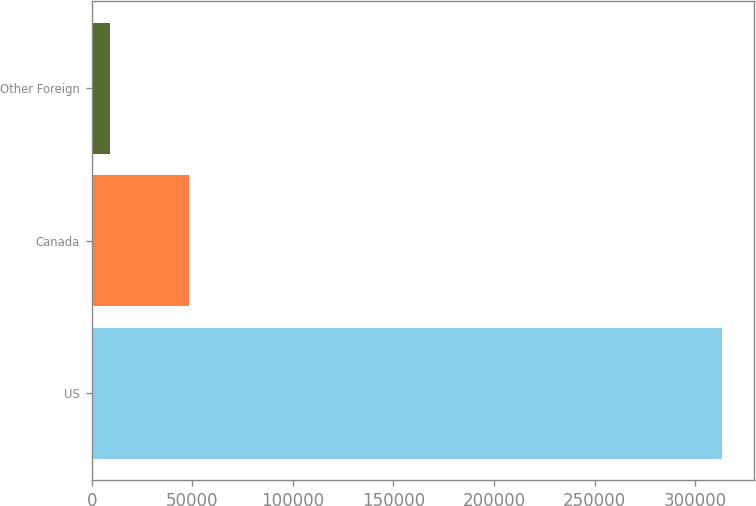Convert chart to OTSL. <chart><loc_0><loc_0><loc_500><loc_500><bar_chart><fcel>US<fcel>Canada<fcel>Other Foreign<nl><fcel>313530<fcel>48327<fcel>8957<nl></chart> 